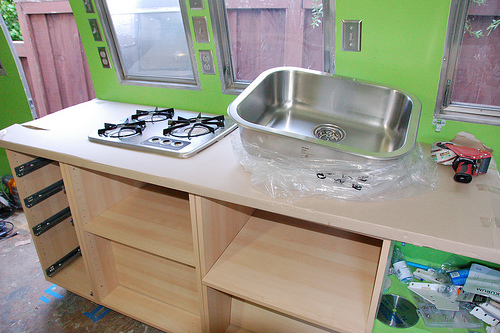<image>
Is there a sink behind the cabinet? No. The sink is not behind the cabinet. From this viewpoint, the sink appears to be positioned elsewhere in the scene. 